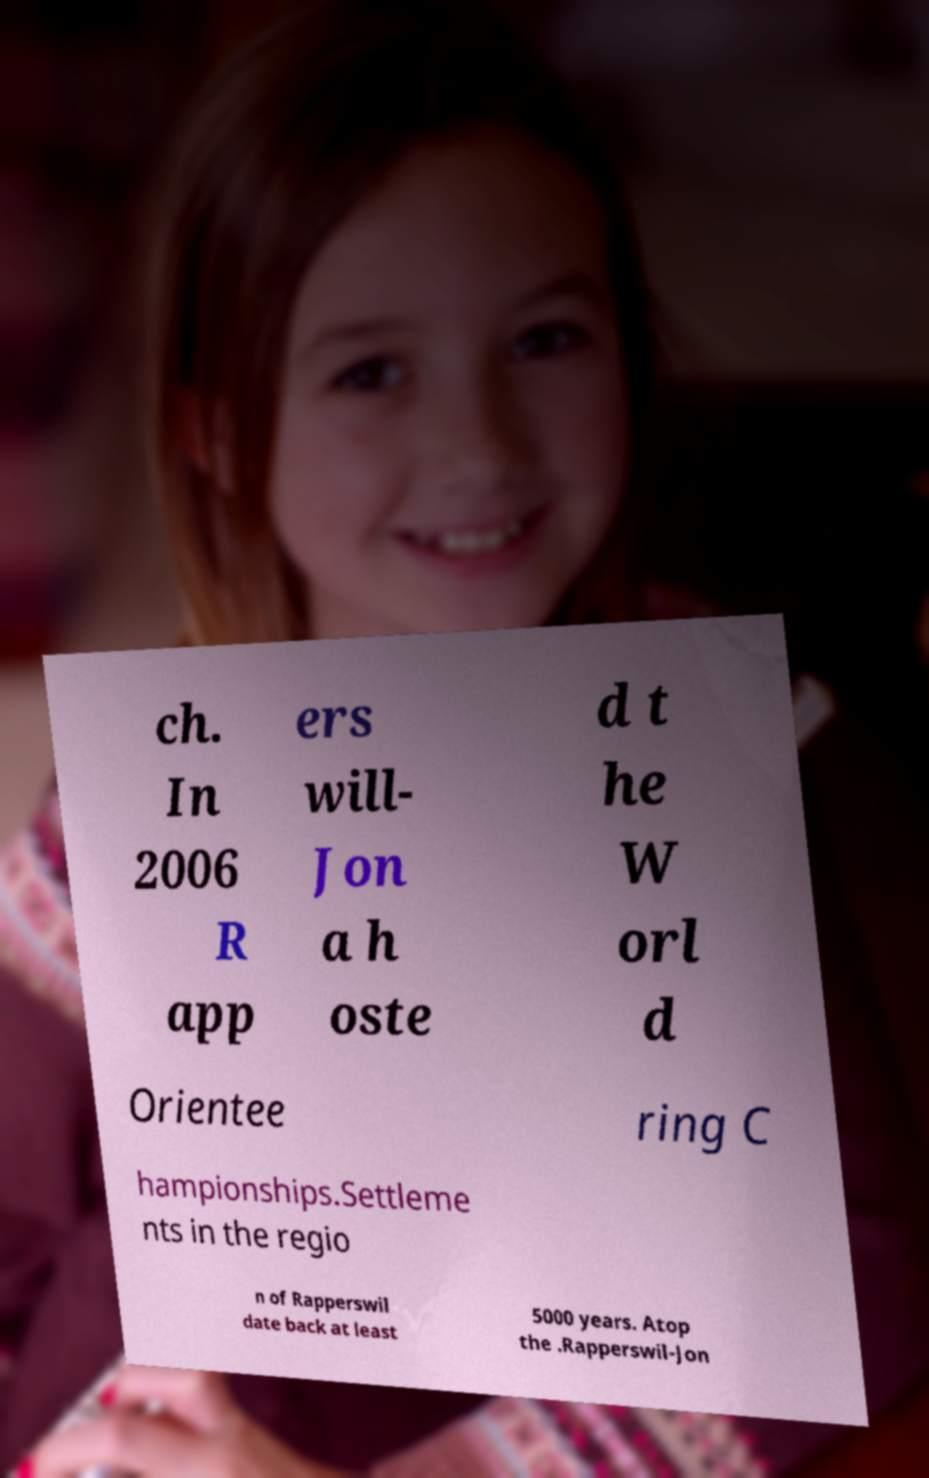What messages or text are displayed in this image? I need them in a readable, typed format. ch. In 2006 R app ers will- Jon a h oste d t he W orl d Orientee ring C hampionships.Settleme nts in the regio n of Rapperswil date back at least 5000 years. Atop the .Rapperswil-Jon 